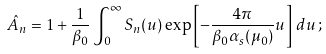<formula> <loc_0><loc_0><loc_500><loc_500>\hat { A } _ { n } = 1 + \frac { 1 } { \beta _ { 0 } } \int _ { 0 } ^ { \infty } S _ { n } ( u ) \exp \left [ - \frac { 4 \pi } { \beta _ { 0 } \alpha _ { s } ( \mu _ { 0 } ) } u \right ] \, d u \, ;</formula> 